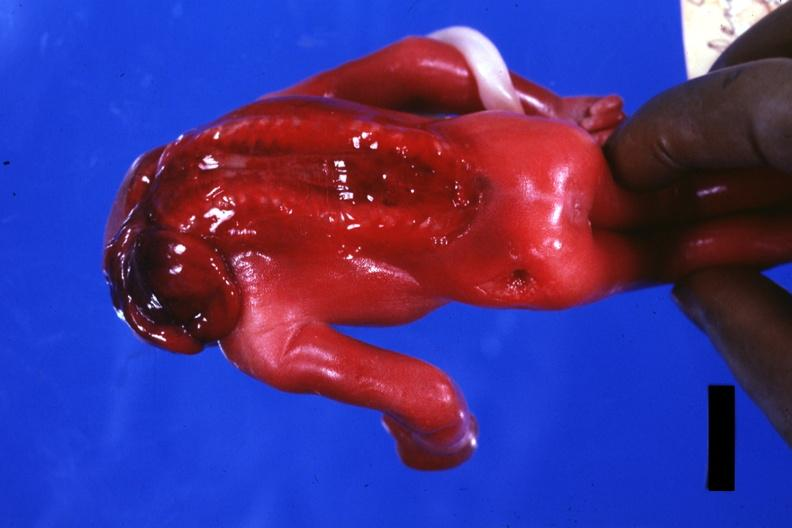s liver with tuberculoid granuloma in glissons present?
Answer the question using a single word or phrase. No 